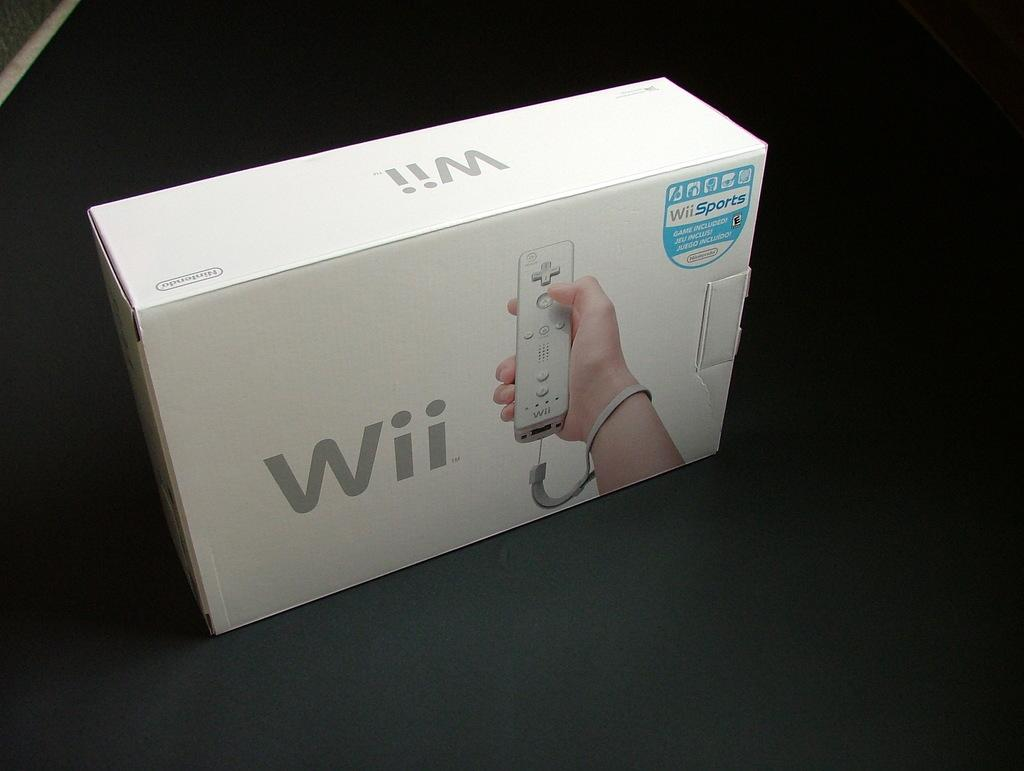<image>
Summarize the visual content of the image. A Wii box showing a hand holding a controller is on a black surface.. 